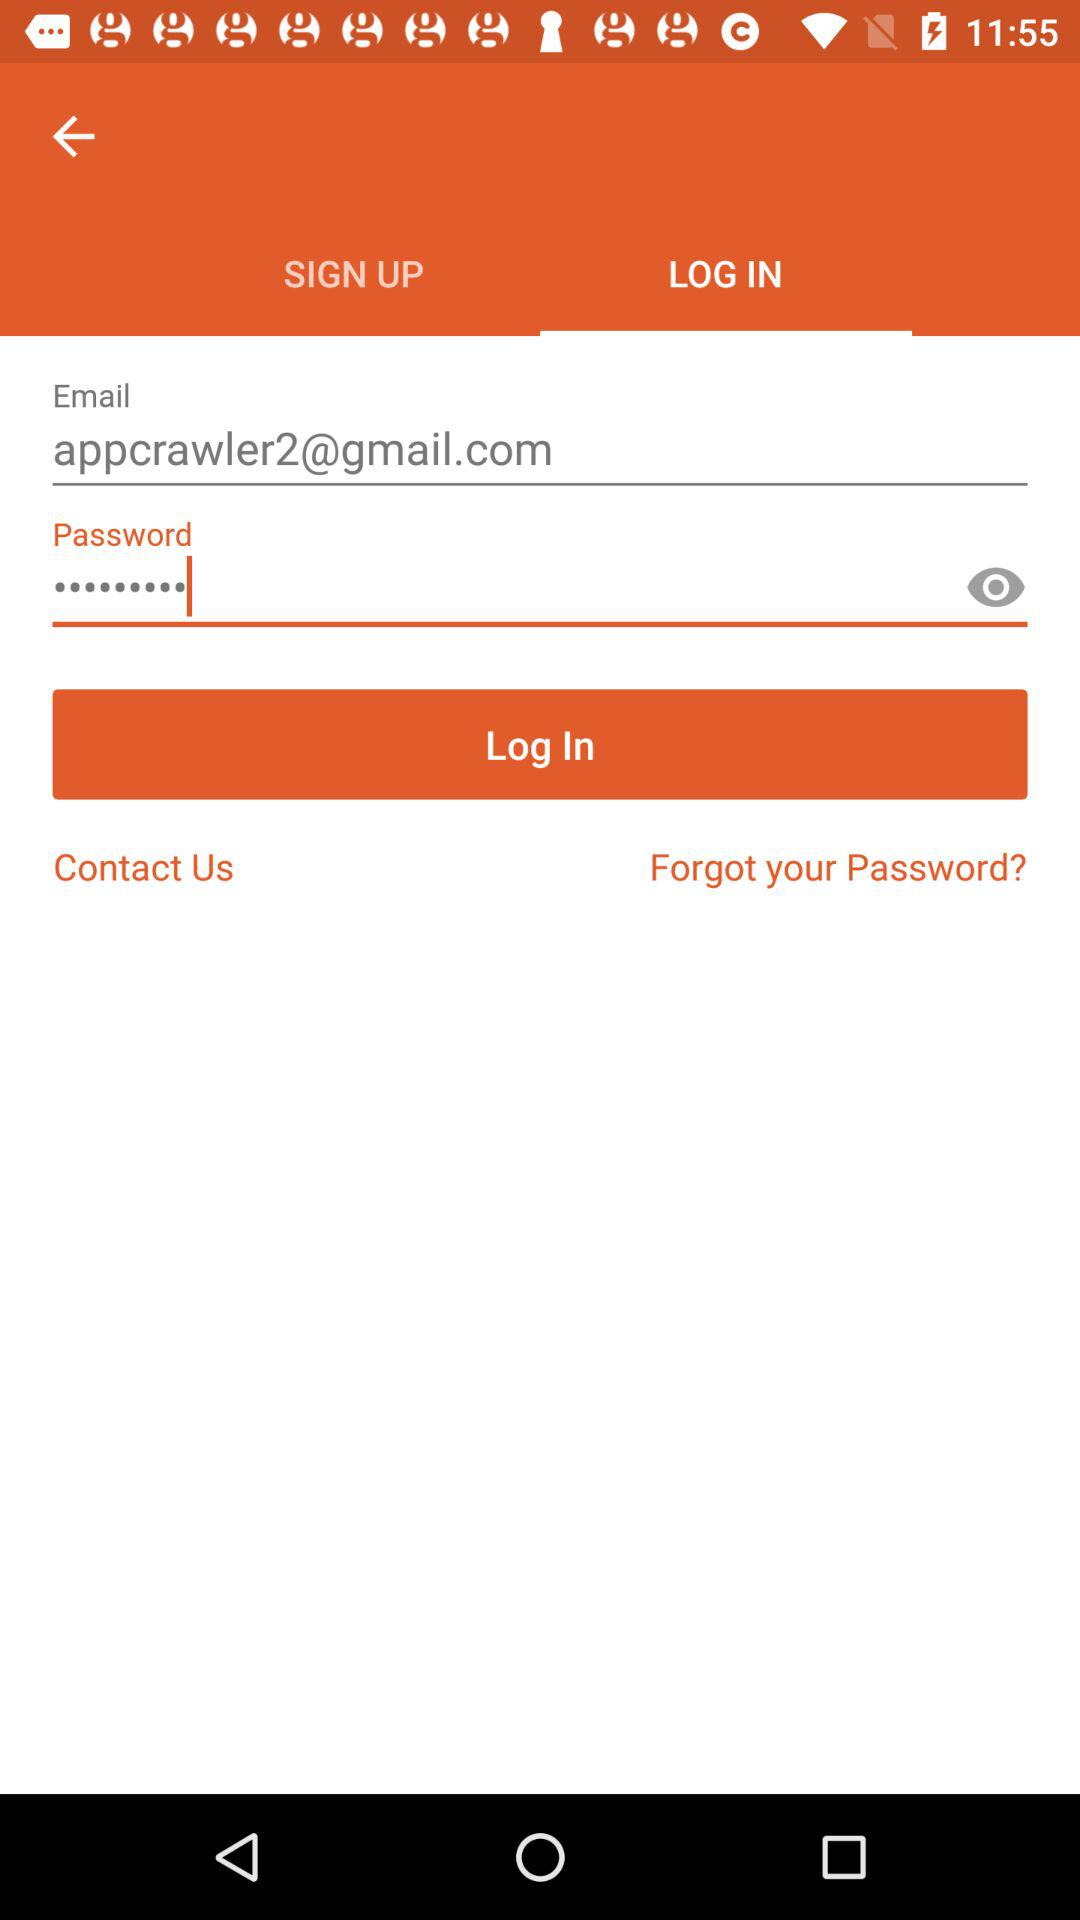What is the email address? The email address is appcrawler2@gmail.com. 